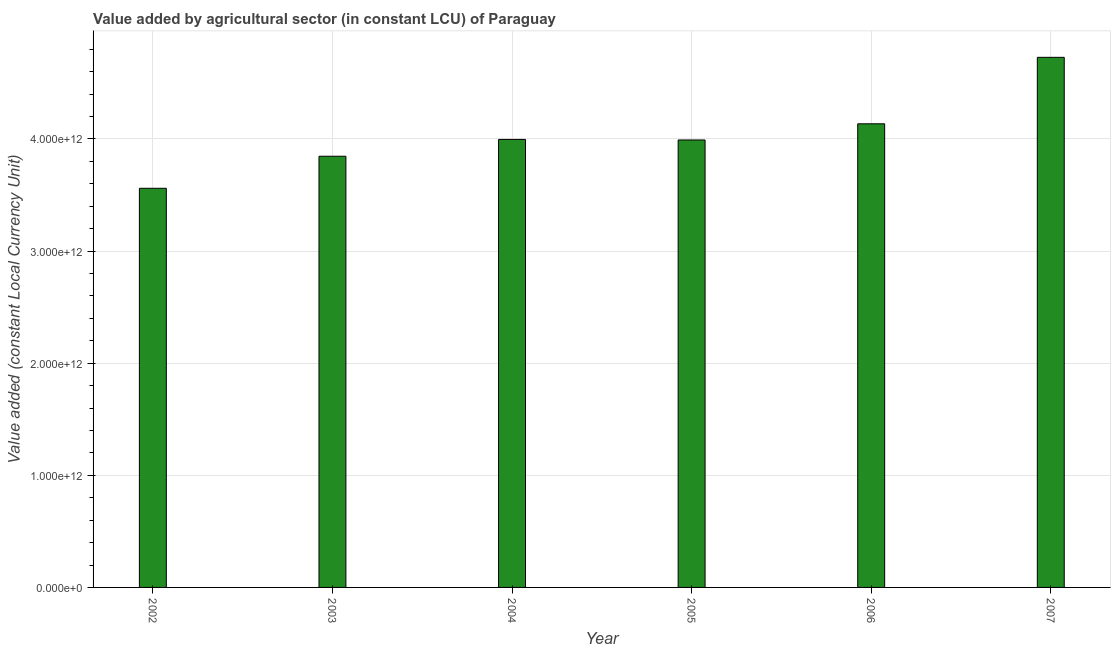Does the graph contain any zero values?
Provide a short and direct response. No. Does the graph contain grids?
Provide a succinct answer. Yes. What is the title of the graph?
Keep it short and to the point. Value added by agricultural sector (in constant LCU) of Paraguay. What is the label or title of the Y-axis?
Ensure brevity in your answer.  Value added (constant Local Currency Unit). What is the value added by agriculture sector in 2005?
Your answer should be very brief. 3.99e+12. Across all years, what is the maximum value added by agriculture sector?
Your answer should be very brief. 4.73e+12. Across all years, what is the minimum value added by agriculture sector?
Your answer should be compact. 3.56e+12. What is the sum of the value added by agriculture sector?
Give a very brief answer. 2.43e+13. What is the difference between the value added by agriculture sector in 2002 and 2005?
Offer a very short reply. -4.31e+11. What is the average value added by agriculture sector per year?
Ensure brevity in your answer.  4.04e+12. What is the median value added by agriculture sector?
Give a very brief answer. 3.99e+12. In how many years, is the value added by agriculture sector greater than 400000000000 LCU?
Your answer should be compact. 6. What is the ratio of the value added by agriculture sector in 2002 to that in 2004?
Ensure brevity in your answer.  0.89. What is the difference between the highest and the second highest value added by agriculture sector?
Give a very brief answer. 5.93e+11. What is the difference between the highest and the lowest value added by agriculture sector?
Provide a succinct answer. 1.17e+12. How many bars are there?
Keep it short and to the point. 6. Are all the bars in the graph horizontal?
Your answer should be very brief. No. What is the difference between two consecutive major ticks on the Y-axis?
Provide a short and direct response. 1.00e+12. Are the values on the major ticks of Y-axis written in scientific E-notation?
Your answer should be compact. Yes. What is the Value added (constant Local Currency Unit) of 2002?
Offer a terse response. 3.56e+12. What is the Value added (constant Local Currency Unit) of 2003?
Your answer should be compact. 3.85e+12. What is the Value added (constant Local Currency Unit) in 2004?
Your answer should be compact. 4.00e+12. What is the Value added (constant Local Currency Unit) in 2005?
Provide a short and direct response. 3.99e+12. What is the Value added (constant Local Currency Unit) of 2006?
Your response must be concise. 4.13e+12. What is the Value added (constant Local Currency Unit) of 2007?
Your response must be concise. 4.73e+12. What is the difference between the Value added (constant Local Currency Unit) in 2002 and 2003?
Ensure brevity in your answer.  -2.86e+11. What is the difference between the Value added (constant Local Currency Unit) in 2002 and 2004?
Keep it short and to the point. -4.36e+11. What is the difference between the Value added (constant Local Currency Unit) in 2002 and 2005?
Offer a very short reply. -4.31e+11. What is the difference between the Value added (constant Local Currency Unit) in 2002 and 2006?
Provide a short and direct response. -5.75e+11. What is the difference between the Value added (constant Local Currency Unit) in 2002 and 2007?
Give a very brief answer. -1.17e+12. What is the difference between the Value added (constant Local Currency Unit) in 2003 and 2004?
Offer a terse response. -1.50e+11. What is the difference between the Value added (constant Local Currency Unit) in 2003 and 2005?
Make the answer very short. -1.45e+11. What is the difference between the Value added (constant Local Currency Unit) in 2003 and 2006?
Your answer should be compact. -2.89e+11. What is the difference between the Value added (constant Local Currency Unit) in 2003 and 2007?
Give a very brief answer. -8.82e+11. What is the difference between the Value added (constant Local Currency Unit) in 2004 and 2005?
Keep it short and to the point. 4.87e+09. What is the difference between the Value added (constant Local Currency Unit) in 2004 and 2006?
Give a very brief answer. -1.39e+11. What is the difference between the Value added (constant Local Currency Unit) in 2004 and 2007?
Your answer should be very brief. -7.32e+11. What is the difference between the Value added (constant Local Currency Unit) in 2005 and 2006?
Keep it short and to the point. -1.44e+11. What is the difference between the Value added (constant Local Currency Unit) in 2005 and 2007?
Your answer should be compact. -7.37e+11. What is the difference between the Value added (constant Local Currency Unit) in 2006 and 2007?
Keep it short and to the point. -5.93e+11. What is the ratio of the Value added (constant Local Currency Unit) in 2002 to that in 2003?
Keep it short and to the point. 0.93. What is the ratio of the Value added (constant Local Currency Unit) in 2002 to that in 2004?
Keep it short and to the point. 0.89. What is the ratio of the Value added (constant Local Currency Unit) in 2002 to that in 2005?
Offer a terse response. 0.89. What is the ratio of the Value added (constant Local Currency Unit) in 2002 to that in 2006?
Offer a terse response. 0.86. What is the ratio of the Value added (constant Local Currency Unit) in 2002 to that in 2007?
Provide a short and direct response. 0.75. What is the ratio of the Value added (constant Local Currency Unit) in 2003 to that in 2006?
Your answer should be compact. 0.93. What is the ratio of the Value added (constant Local Currency Unit) in 2003 to that in 2007?
Make the answer very short. 0.81. What is the ratio of the Value added (constant Local Currency Unit) in 2004 to that in 2005?
Make the answer very short. 1. What is the ratio of the Value added (constant Local Currency Unit) in 2004 to that in 2007?
Your answer should be very brief. 0.84. What is the ratio of the Value added (constant Local Currency Unit) in 2005 to that in 2007?
Provide a short and direct response. 0.84. 